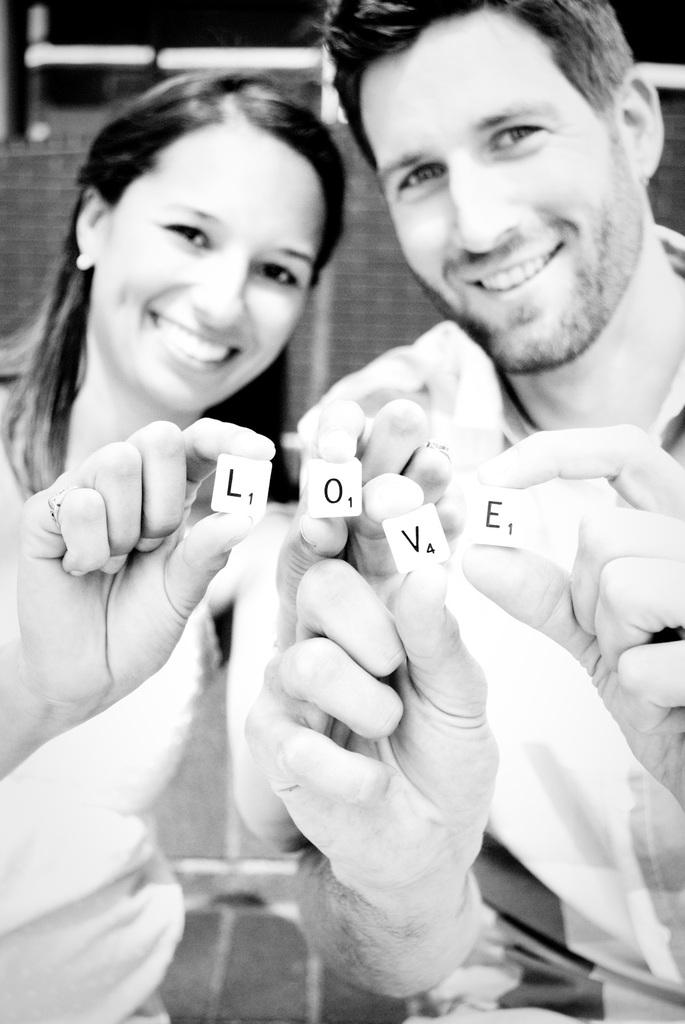Who is present in the image? There is a man and a woman in the image. What are the facial expressions of the people in the image? Both the man and woman are smiling in the image. What is the color scheme of the image? The image is in black and white. What arithmetic problem is the man solving in the image? There is no arithmetic problem present in the image; it only shows the man and woman smiling. What is the current temperature in the image? The image does not provide any information about the temperature; it is a photograph of two people smiling. 